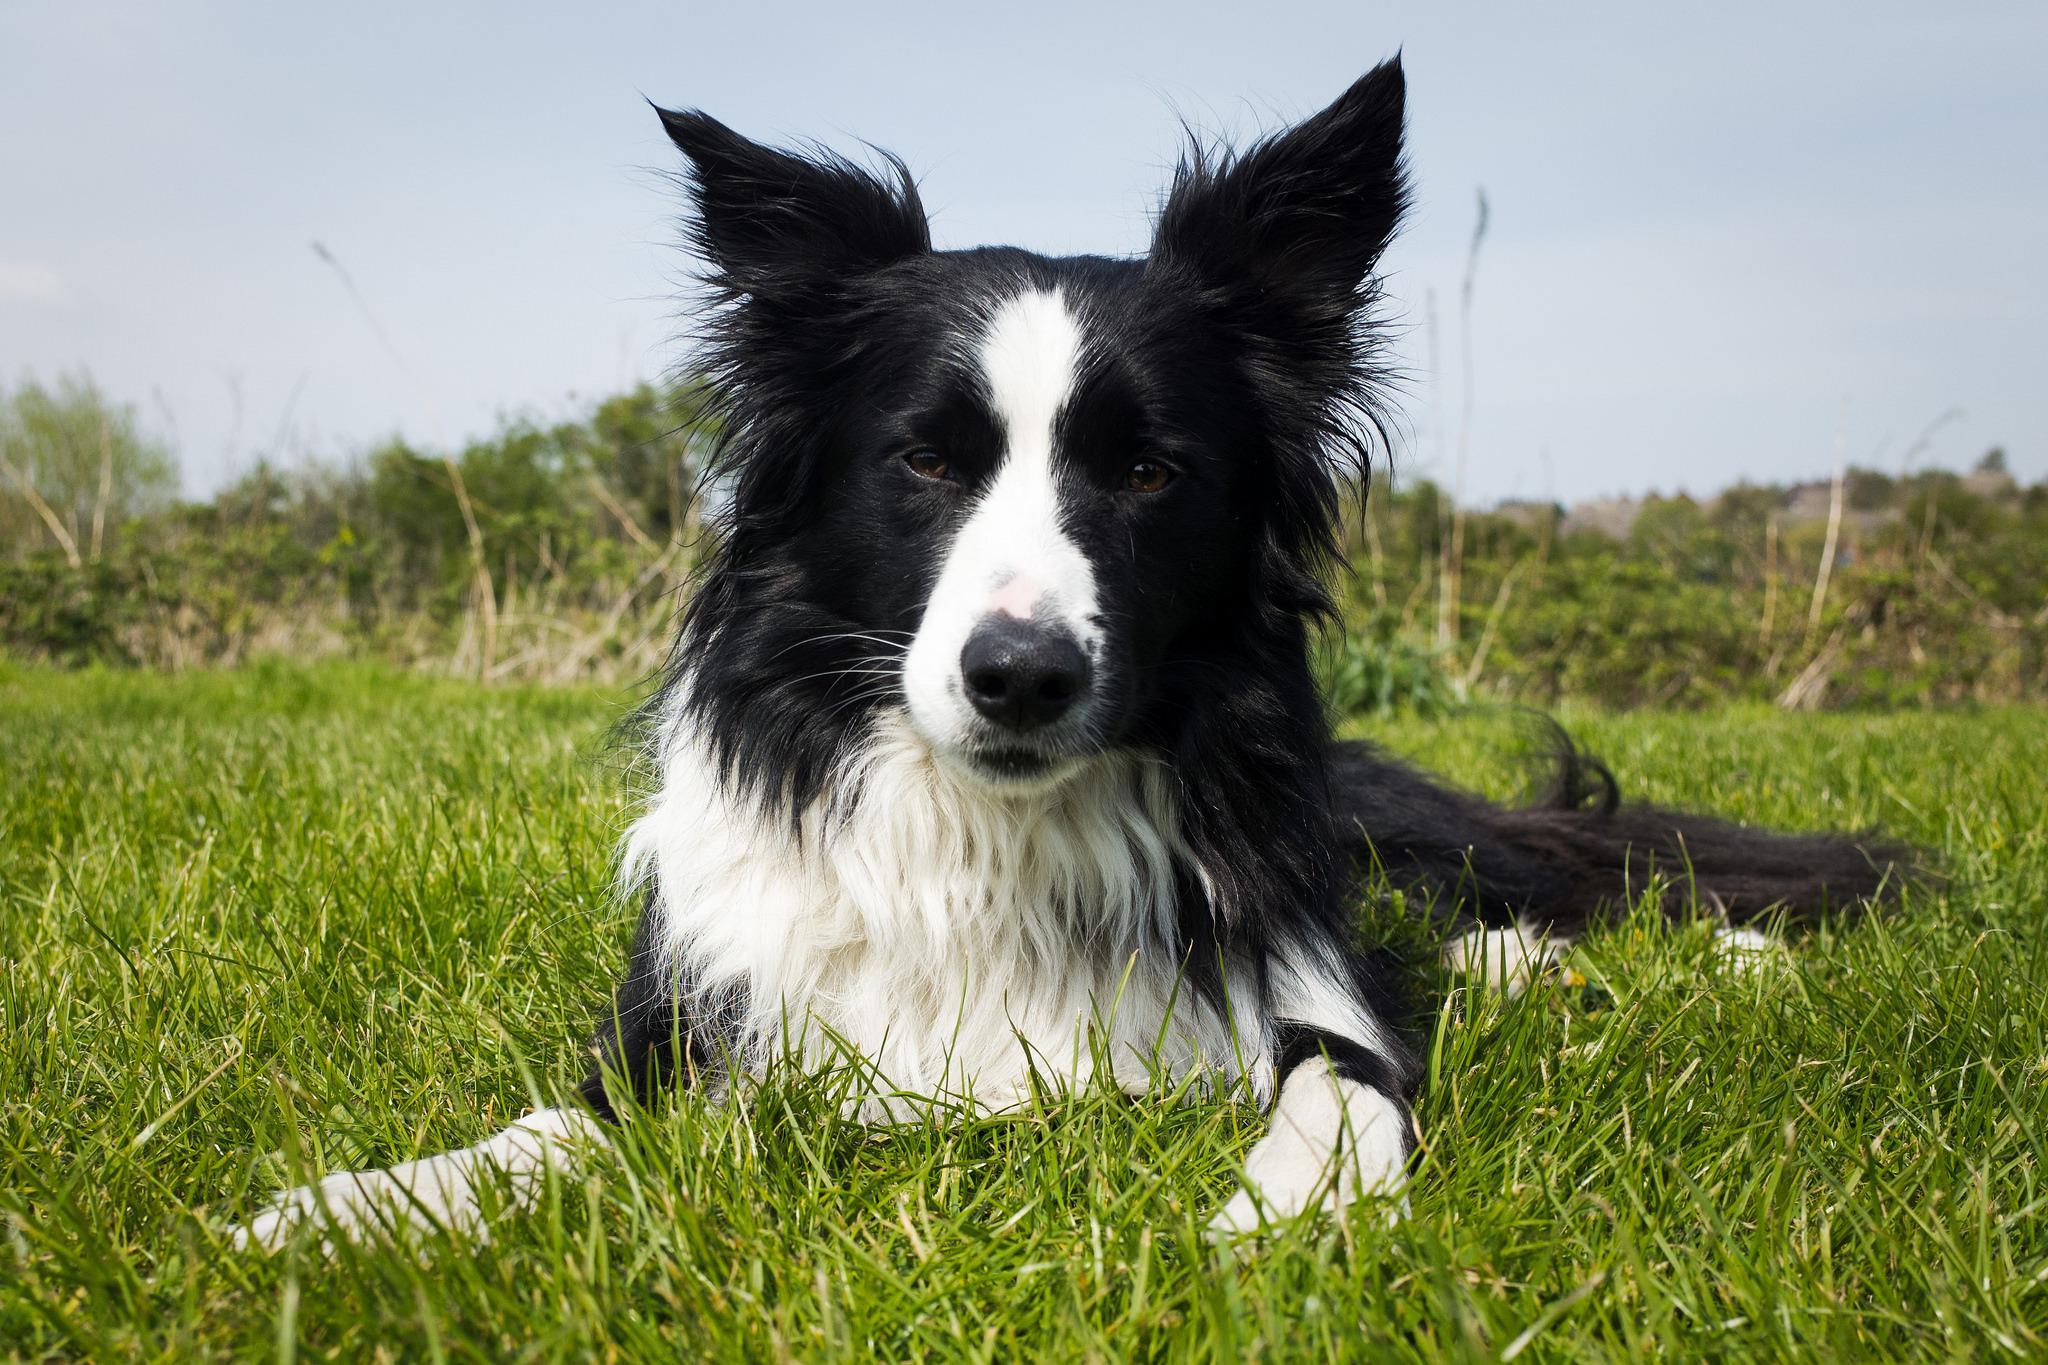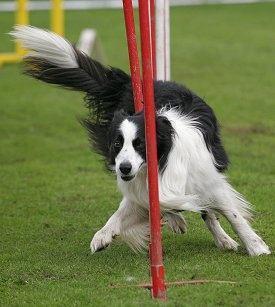The first image is the image on the left, the second image is the image on the right. For the images shown, is this caption "An image shows a dog reclining on the grass with its head cocked at a sharp angle." true? Answer yes or no. No. The first image is the image on the left, the second image is the image on the right. Analyze the images presented: Is the assertion "The dog in one of the images has its head tilted to the side." valid? Answer yes or no. No. 